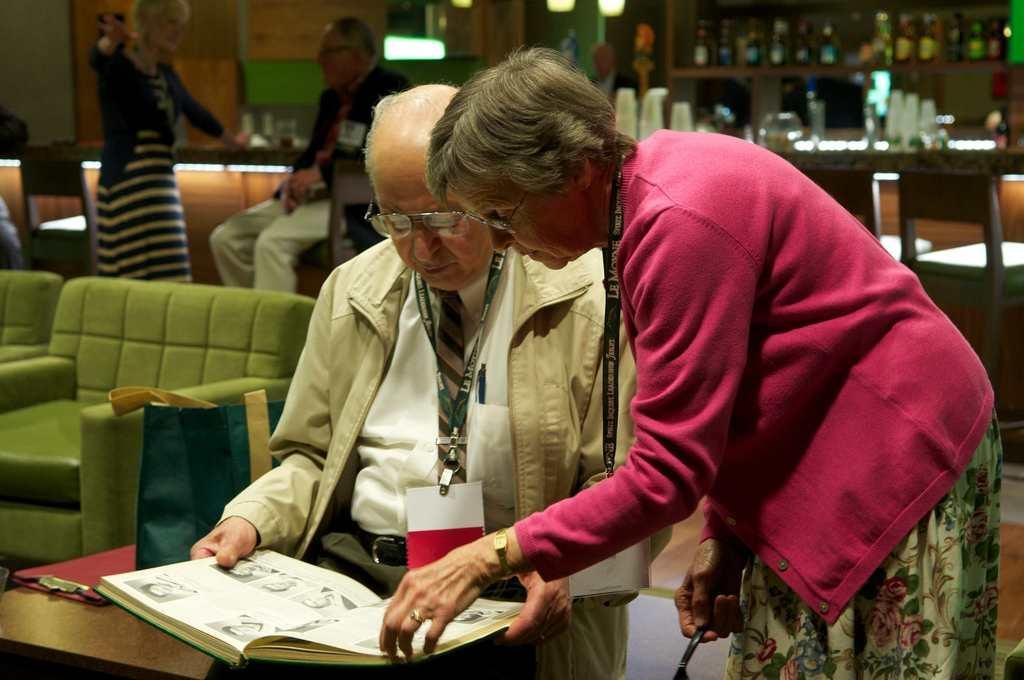Could you give a brief overview of what you see in this image? In the foreground of this image, there is a man holding a book and wearing an ID card. Beside him, there is a woman standing and it seems like she is holding a spoon. Behind them, there is a bag and an object on a table. We can also see couches, a man sitting on a chair and a woman standing. In the background, there are bottles in the rack, few objects on the desk, chairs, lights and the wall. 